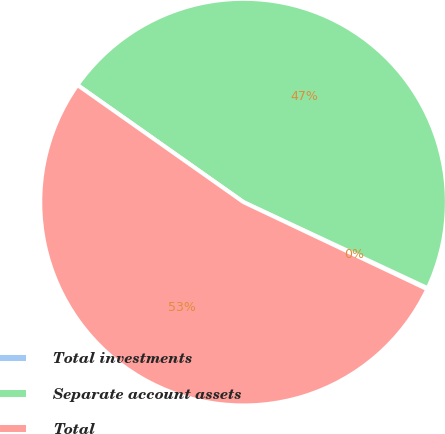Convert chart. <chart><loc_0><loc_0><loc_500><loc_500><pie_chart><fcel>Total investments<fcel>Separate account assets<fcel>Total<nl><fcel>0.09%<fcel>47.18%<fcel>52.73%<nl></chart> 